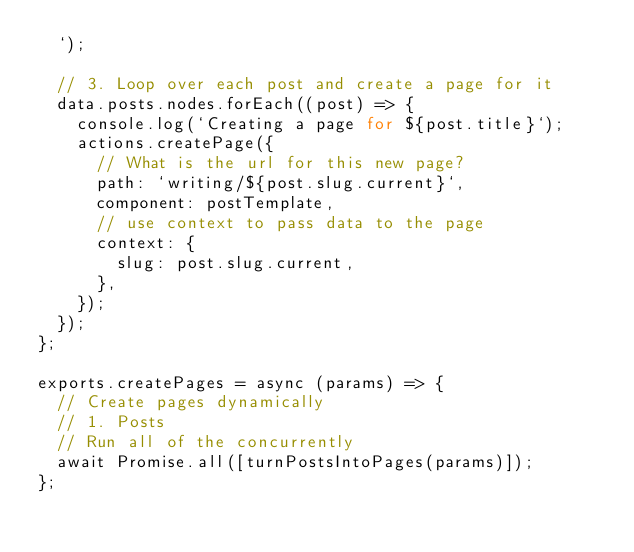<code> <loc_0><loc_0><loc_500><loc_500><_JavaScript_>  `);

  // 3. Loop over each post and create a page for it
  data.posts.nodes.forEach((post) => {
    console.log(`Creating a page for ${post.title}`);
    actions.createPage({
      // What is the url for this new page?
      path: `writing/${post.slug.current}`,
      component: postTemplate,
      // use context to pass data to the page
      context: {
        slug: post.slug.current,
      },
    });
  });
};

exports.createPages = async (params) => {
  // Create pages dynamically
  // 1. Posts
  // Run all of the concurrently
  await Promise.all([turnPostsIntoPages(params)]);
};
</code> 